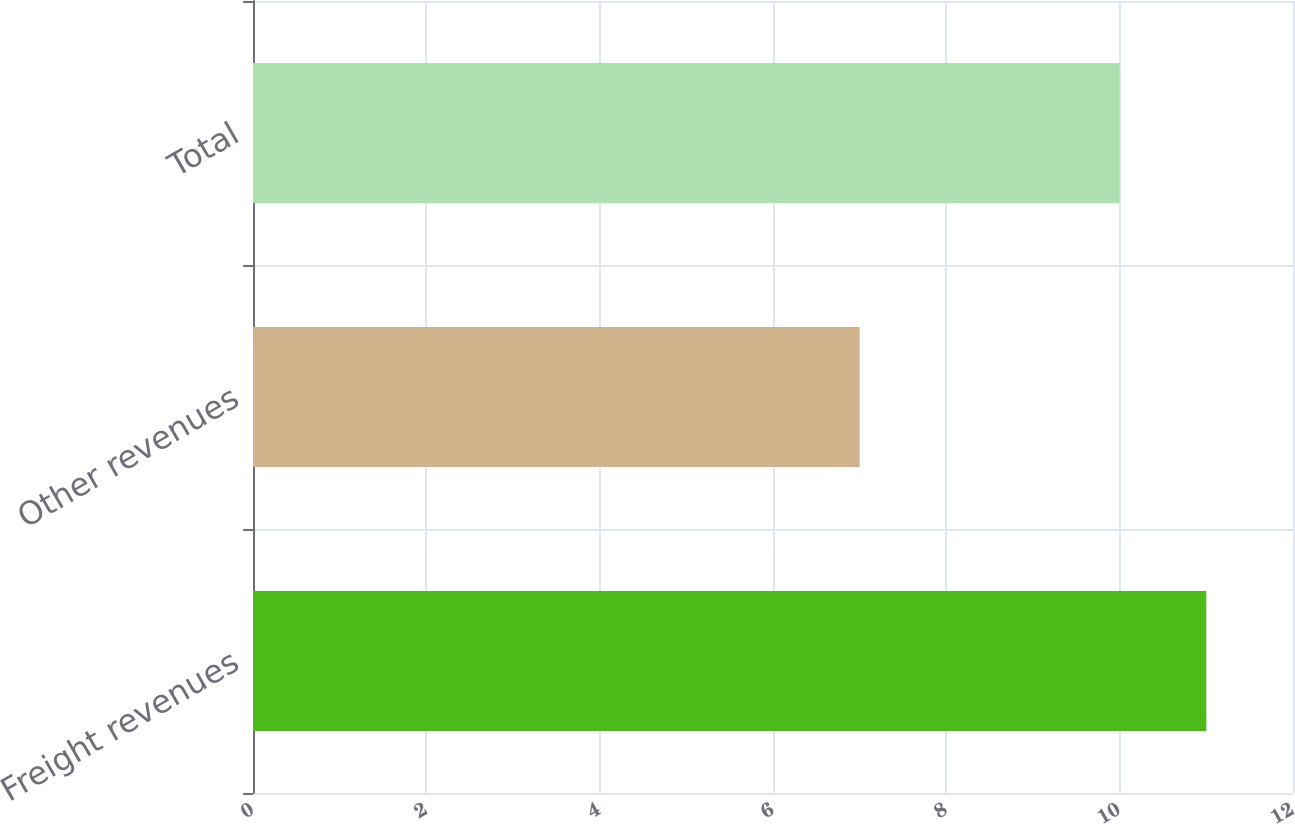Convert chart to OTSL. <chart><loc_0><loc_0><loc_500><loc_500><bar_chart><fcel>Freight revenues<fcel>Other revenues<fcel>Total<nl><fcel>11<fcel>7<fcel>10<nl></chart> 